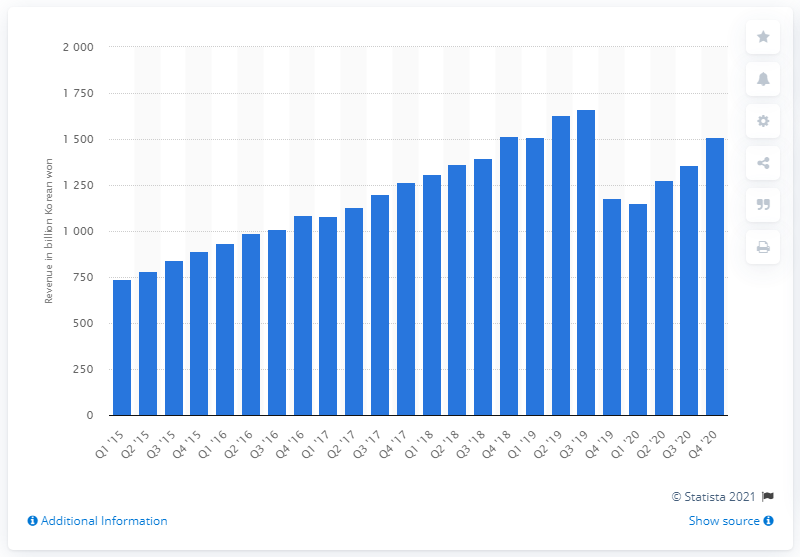Specify some key components in this picture. Naver's revenue in the most recent quarter was 151.26 billion won. 